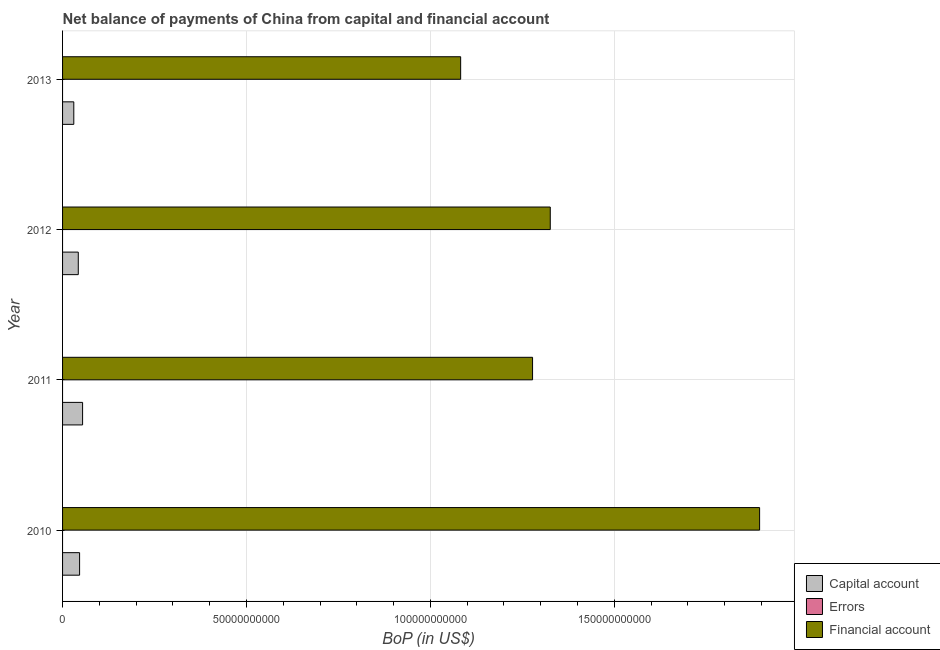How many groups of bars are there?
Your answer should be compact. 4. Are the number of bars per tick equal to the number of legend labels?
Your answer should be very brief. No. What is the label of the 3rd group of bars from the top?
Your answer should be very brief. 2011. In how many cases, is the number of bars for a given year not equal to the number of legend labels?
Provide a short and direct response. 4. What is the amount of net capital account in 2012?
Give a very brief answer. 4.27e+09. Across all years, what is the maximum amount of net capital account?
Your answer should be very brief. 5.45e+09. Across all years, what is the minimum amount of net capital account?
Your response must be concise. 3.05e+09. What is the total amount of net capital account in the graph?
Offer a terse response. 1.74e+1. What is the difference between the amount of net capital account in 2010 and that in 2013?
Provide a short and direct response. 1.58e+09. What is the difference between the amount of net capital account in 2012 and the amount of errors in 2013?
Your answer should be compact. 4.27e+09. What is the average amount of errors per year?
Provide a short and direct response. 0. In the year 2011, what is the difference between the amount of net capital account and amount of financial account?
Offer a very short reply. -1.22e+11. What is the difference between the highest and the second highest amount of financial account?
Your response must be concise. 5.69e+1. What is the difference between the highest and the lowest amount of net capital account?
Offer a very short reply. 2.39e+09. In how many years, is the amount of errors greater than the average amount of errors taken over all years?
Make the answer very short. 0. Is it the case that in every year, the sum of the amount of net capital account and amount of errors is greater than the amount of financial account?
Make the answer very short. No. Are the values on the major ticks of X-axis written in scientific E-notation?
Provide a short and direct response. No. How many legend labels are there?
Your answer should be compact. 3. What is the title of the graph?
Ensure brevity in your answer.  Net balance of payments of China from capital and financial account. Does "Ireland" appear as one of the legend labels in the graph?
Provide a short and direct response. No. What is the label or title of the X-axis?
Make the answer very short. BoP (in US$). What is the BoP (in US$) in Capital account in 2010?
Your answer should be compact. 4.63e+09. What is the BoP (in US$) of Errors in 2010?
Provide a succinct answer. 0. What is the BoP (in US$) in Financial account in 2010?
Ensure brevity in your answer.  1.90e+11. What is the BoP (in US$) in Capital account in 2011?
Make the answer very short. 5.45e+09. What is the BoP (in US$) of Errors in 2011?
Make the answer very short. 0. What is the BoP (in US$) in Financial account in 2011?
Keep it short and to the point. 1.28e+11. What is the BoP (in US$) of Capital account in 2012?
Provide a succinct answer. 4.27e+09. What is the BoP (in US$) in Errors in 2012?
Keep it short and to the point. 0. What is the BoP (in US$) in Financial account in 2012?
Your answer should be very brief. 1.33e+11. What is the BoP (in US$) in Capital account in 2013?
Offer a terse response. 3.05e+09. What is the BoP (in US$) in Financial account in 2013?
Make the answer very short. 1.08e+11. Across all years, what is the maximum BoP (in US$) of Capital account?
Your response must be concise. 5.45e+09. Across all years, what is the maximum BoP (in US$) of Financial account?
Provide a succinct answer. 1.90e+11. Across all years, what is the minimum BoP (in US$) of Capital account?
Your answer should be compact. 3.05e+09. Across all years, what is the minimum BoP (in US$) of Financial account?
Your response must be concise. 1.08e+11. What is the total BoP (in US$) in Capital account in the graph?
Give a very brief answer. 1.74e+1. What is the total BoP (in US$) in Errors in the graph?
Make the answer very short. 0. What is the total BoP (in US$) of Financial account in the graph?
Your answer should be very brief. 5.58e+11. What is the difference between the BoP (in US$) in Capital account in 2010 and that in 2011?
Provide a succinct answer. -8.16e+08. What is the difference between the BoP (in US$) in Financial account in 2010 and that in 2011?
Give a very brief answer. 6.17e+1. What is the difference between the BoP (in US$) of Capital account in 2010 and that in 2012?
Keep it short and to the point. 3.58e+08. What is the difference between the BoP (in US$) in Financial account in 2010 and that in 2012?
Provide a short and direct response. 5.69e+1. What is the difference between the BoP (in US$) of Capital account in 2010 and that in 2013?
Offer a very short reply. 1.58e+09. What is the difference between the BoP (in US$) of Financial account in 2010 and that in 2013?
Your answer should be very brief. 8.13e+1. What is the difference between the BoP (in US$) of Capital account in 2011 and that in 2012?
Make the answer very short. 1.17e+09. What is the difference between the BoP (in US$) of Financial account in 2011 and that in 2012?
Provide a succinct answer. -4.81e+09. What is the difference between the BoP (in US$) in Capital account in 2011 and that in 2013?
Provide a succinct answer. 2.39e+09. What is the difference between the BoP (in US$) in Financial account in 2011 and that in 2013?
Give a very brief answer. 1.95e+1. What is the difference between the BoP (in US$) of Capital account in 2012 and that in 2013?
Keep it short and to the point. 1.22e+09. What is the difference between the BoP (in US$) of Financial account in 2012 and that in 2013?
Provide a short and direct response. 2.44e+1. What is the difference between the BoP (in US$) in Capital account in 2010 and the BoP (in US$) in Financial account in 2011?
Your answer should be compact. -1.23e+11. What is the difference between the BoP (in US$) of Capital account in 2010 and the BoP (in US$) of Financial account in 2012?
Make the answer very short. -1.28e+11. What is the difference between the BoP (in US$) of Capital account in 2010 and the BoP (in US$) of Financial account in 2013?
Offer a very short reply. -1.04e+11. What is the difference between the BoP (in US$) of Capital account in 2011 and the BoP (in US$) of Financial account in 2012?
Offer a terse response. -1.27e+11. What is the difference between the BoP (in US$) in Capital account in 2011 and the BoP (in US$) in Financial account in 2013?
Provide a short and direct response. -1.03e+11. What is the difference between the BoP (in US$) of Capital account in 2012 and the BoP (in US$) of Financial account in 2013?
Make the answer very short. -1.04e+11. What is the average BoP (in US$) of Capital account per year?
Offer a very short reply. 4.35e+09. What is the average BoP (in US$) in Errors per year?
Provide a short and direct response. 0. What is the average BoP (in US$) in Financial account per year?
Make the answer very short. 1.40e+11. In the year 2010, what is the difference between the BoP (in US$) of Capital account and BoP (in US$) of Financial account?
Your answer should be very brief. -1.85e+11. In the year 2011, what is the difference between the BoP (in US$) of Capital account and BoP (in US$) of Financial account?
Provide a succinct answer. -1.22e+11. In the year 2012, what is the difference between the BoP (in US$) in Capital account and BoP (in US$) in Financial account?
Offer a very short reply. -1.28e+11. In the year 2013, what is the difference between the BoP (in US$) of Capital account and BoP (in US$) of Financial account?
Provide a short and direct response. -1.05e+11. What is the ratio of the BoP (in US$) in Capital account in 2010 to that in 2011?
Provide a short and direct response. 0.85. What is the ratio of the BoP (in US$) in Financial account in 2010 to that in 2011?
Make the answer very short. 1.48. What is the ratio of the BoP (in US$) of Capital account in 2010 to that in 2012?
Make the answer very short. 1.08. What is the ratio of the BoP (in US$) in Financial account in 2010 to that in 2012?
Offer a terse response. 1.43. What is the ratio of the BoP (in US$) in Capital account in 2010 to that in 2013?
Provide a short and direct response. 1.52. What is the ratio of the BoP (in US$) in Financial account in 2010 to that in 2013?
Provide a short and direct response. 1.75. What is the ratio of the BoP (in US$) of Capital account in 2011 to that in 2012?
Your response must be concise. 1.27. What is the ratio of the BoP (in US$) in Financial account in 2011 to that in 2012?
Ensure brevity in your answer.  0.96. What is the ratio of the BoP (in US$) in Capital account in 2011 to that in 2013?
Your response must be concise. 1.78. What is the ratio of the BoP (in US$) in Financial account in 2011 to that in 2013?
Provide a succinct answer. 1.18. What is the ratio of the BoP (in US$) in Capital account in 2012 to that in 2013?
Ensure brevity in your answer.  1.4. What is the ratio of the BoP (in US$) in Financial account in 2012 to that in 2013?
Your answer should be compact. 1.23. What is the difference between the highest and the second highest BoP (in US$) in Capital account?
Offer a very short reply. 8.16e+08. What is the difference between the highest and the second highest BoP (in US$) of Financial account?
Keep it short and to the point. 5.69e+1. What is the difference between the highest and the lowest BoP (in US$) in Capital account?
Offer a terse response. 2.39e+09. What is the difference between the highest and the lowest BoP (in US$) in Financial account?
Ensure brevity in your answer.  8.13e+1. 